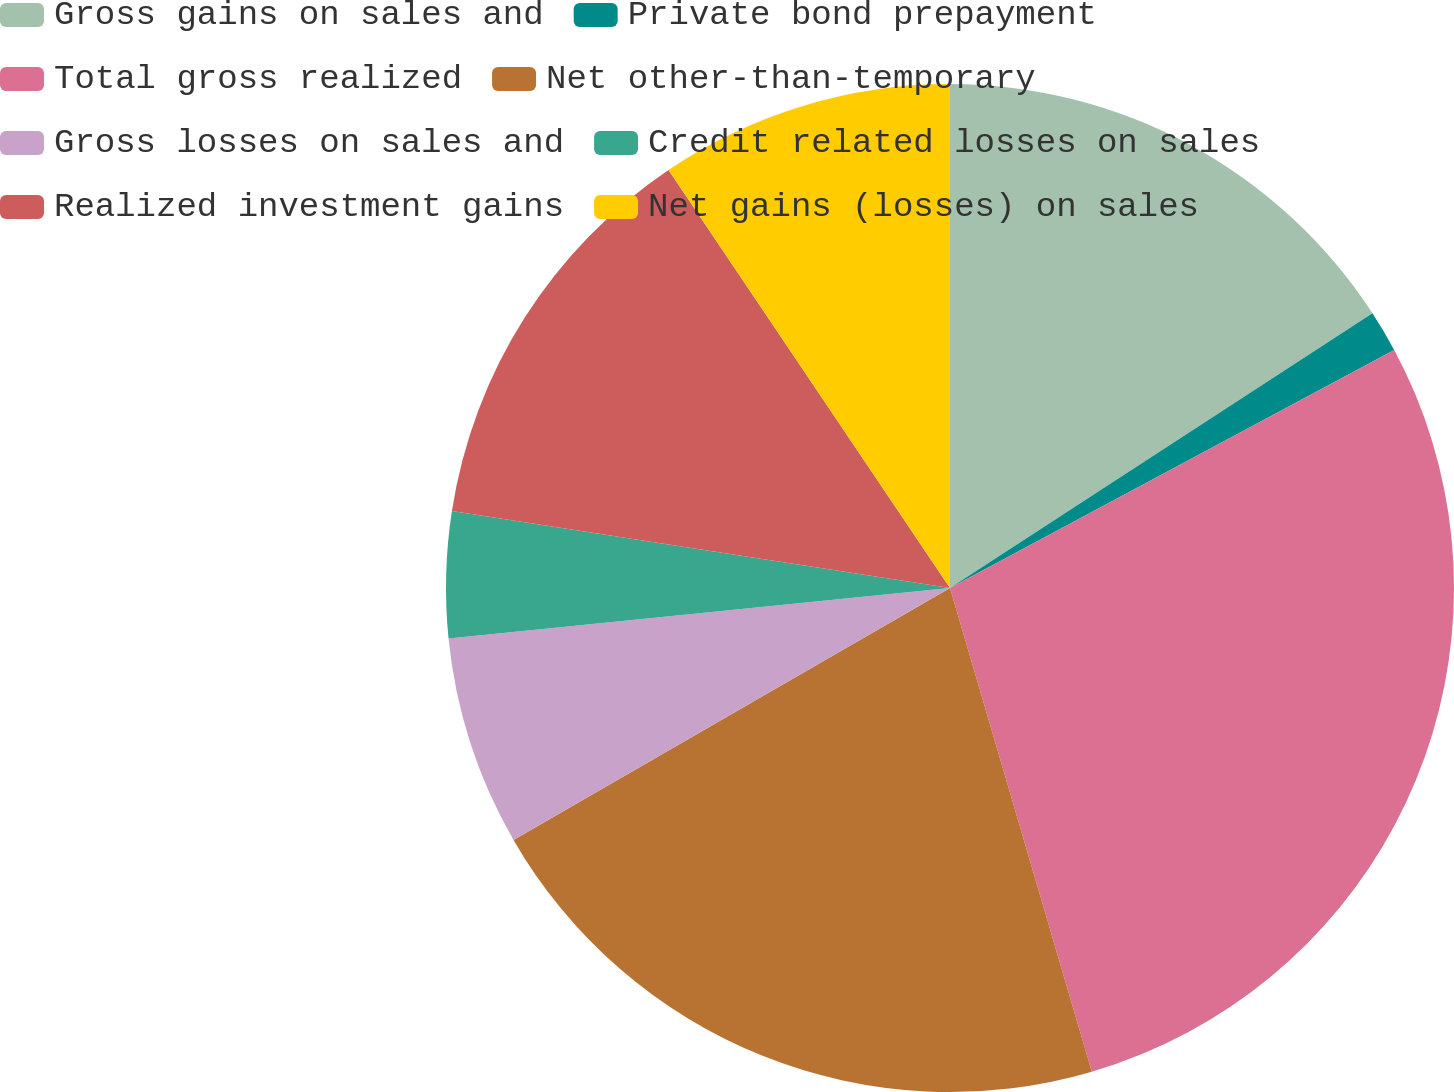Convert chart to OTSL. <chart><loc_0><loc_0><loc_500><loc_500><pie_chart><fcel>Gross gains on sales and<fcel>Private bond prepayment<fcel>Total gross realized<fcel>Net other-than-temporary<fcel>Gross losses on sales and<fcel>Credit related losses on sales<fcel>Realized investment gains<fcel>Net gains (losses) on sales<nl><fcel>15.82%<fcel>1.35%<fcel>28.29%<fcel>21.21%<fcel>6.73%<fcel>4.04%<fcel>13.13%<fcel>9.43%<nl></chart> 